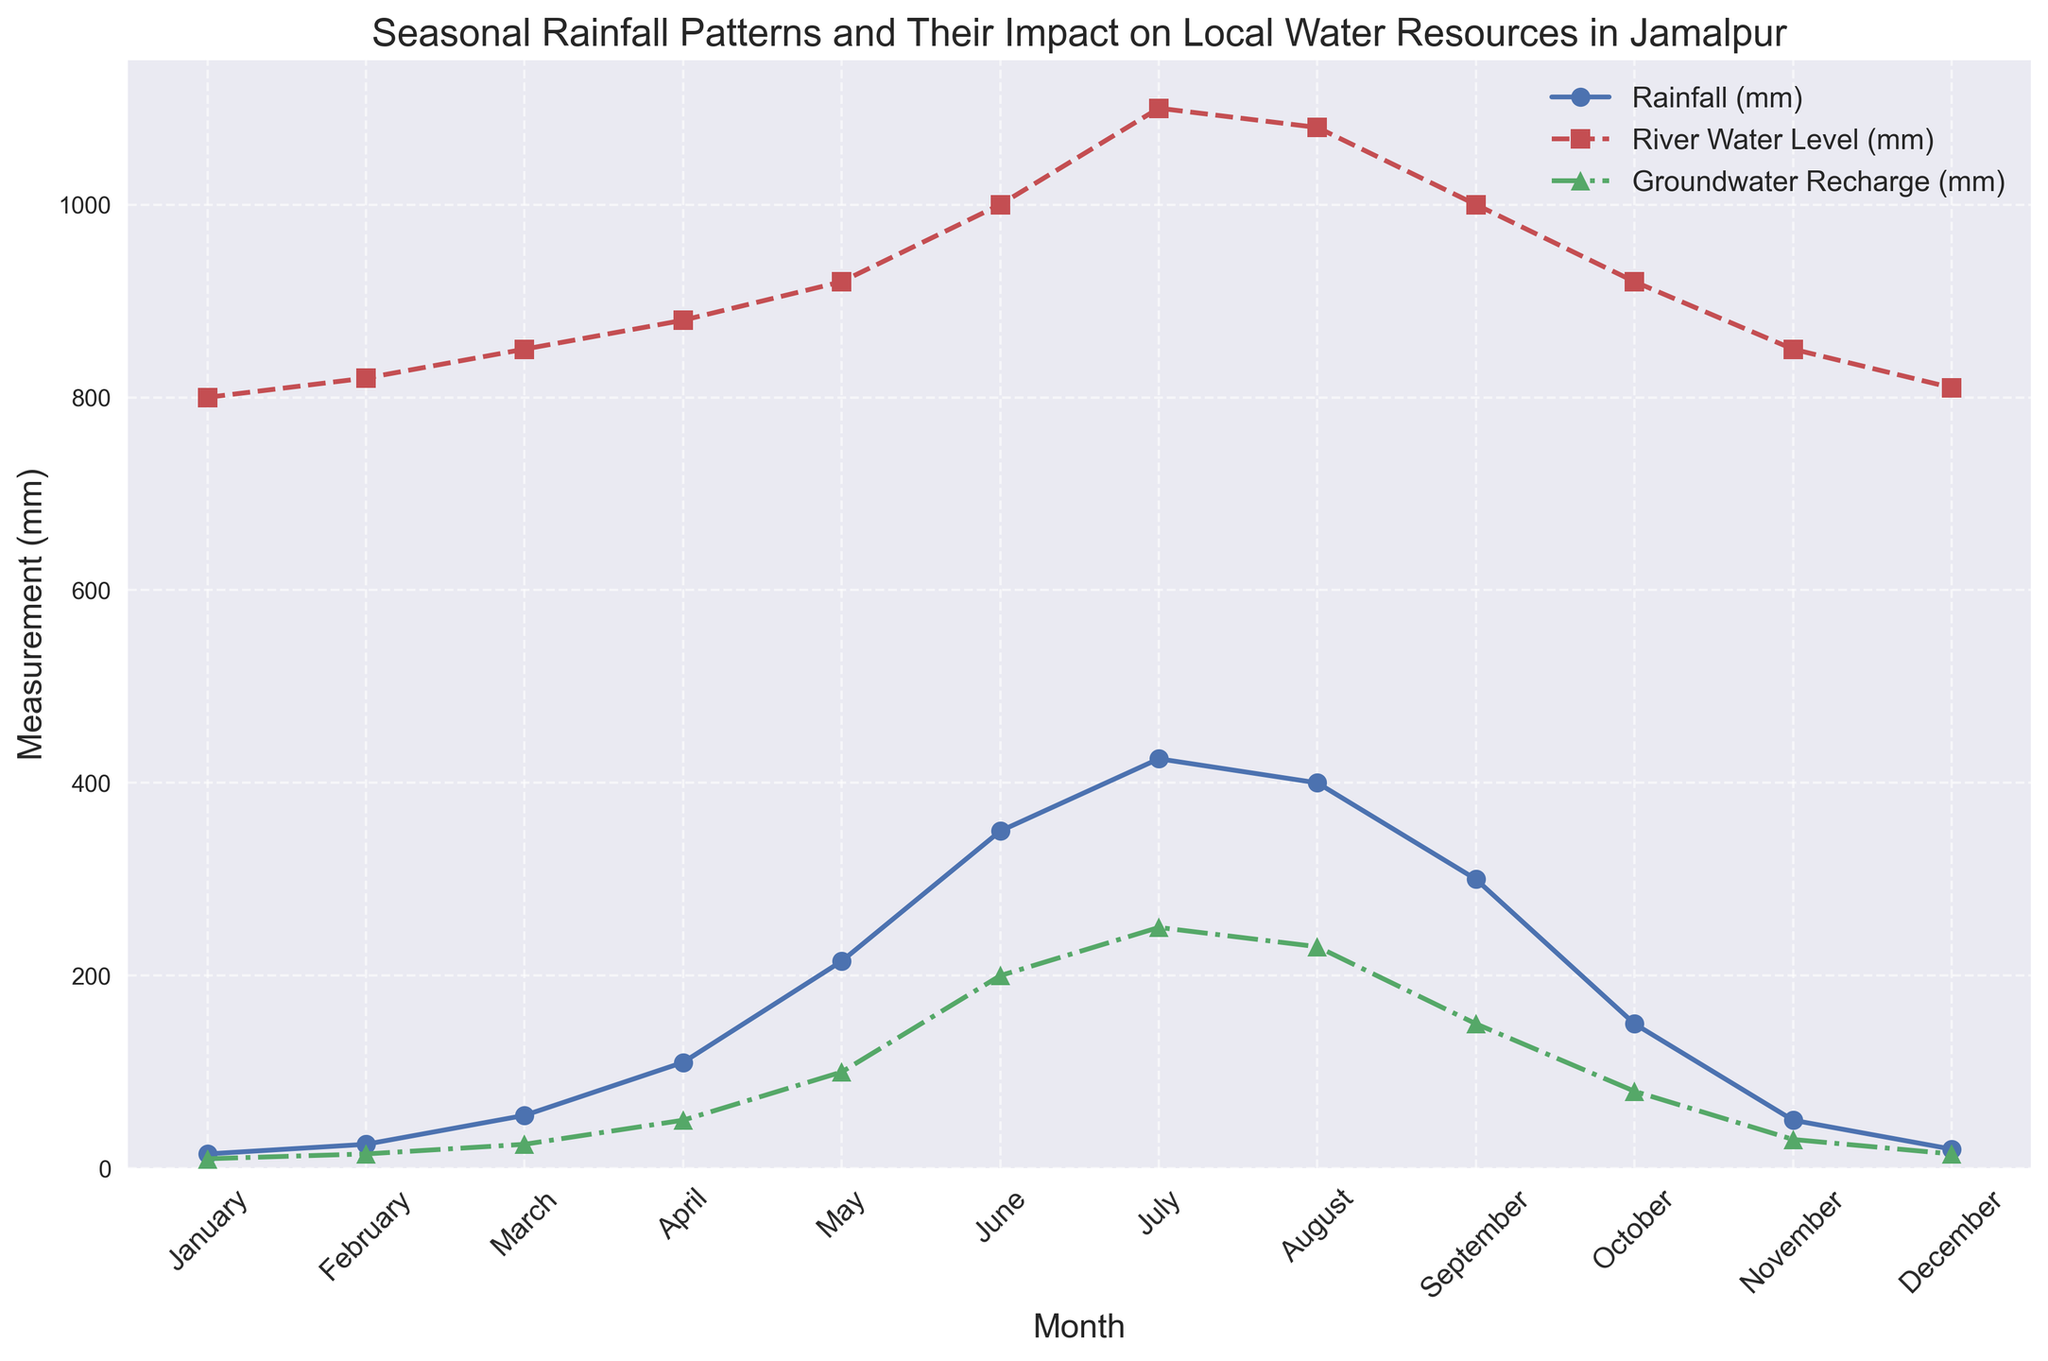Which month has the highest rainfall? The highest peak on the blue line represents the month of July with the highest rainfall.
Answer: July How does groundwater recharge in August compare with May? The green line indicates groundwater recharge in August is higher than in May (230 mm compared to 100 mm).
Answer: Higher in August What is the difference between the river water level in March and April? The red line shows the river water level in March at 850 mm and in April at 880 mm, the difference is 880 mm - 850 mm.
Answer: 30 mm Which months experience the highest groundwater recharge? The peaks on the green line indicate the highest groundwater recharge is in July, followed by June.
Answer: July What is the trend in rainfall from January to April? The blue line shows a constant increase in rainfall from January (15 mm) to April (110 mm).
Answer: Increasing Is the river water level in June greater than in October? The red line shows the river water level in June (1000 mm) is greater than in October (920 mm).
Answer: Yes What is the sum of rainfall in May and June? Add rainfall in May (215 mm) and June (350 mm) as shown by the peaks on the blue line: 215 mm + 350 mm.
Answer: 565 mm What is the average groundwater recharge from February to April? Sum of groundwater recharge from February (15 mm), March (25 mm), and April (50 mm) is 15 + 25 + 50 = 90 mm, and the average is 90/3.
Answer: 30 mm Which month shows the lowest river water level? The lowest point on the red line shows January with the lowest river water level at 800 mm.
Answer: January 